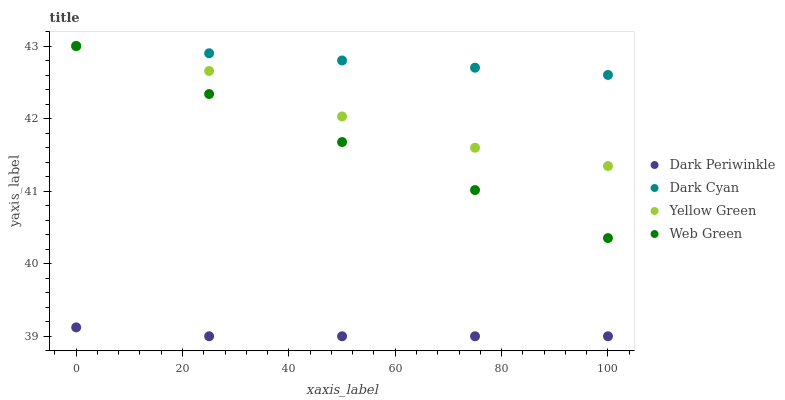Does Dark Periwinkle have the minimum area under the curve?
Answer yes or no. Yes. Does Dark Cyan have the maximum area under the curve?
Answer yes or no. Yes. Does Web Green have the minimum area under the curve?
Answer yes or no. No. Does Web Green have the maximum area under the curve?
Answer yes or no. No. Is Dark Cyan the smoothest?
Answer yes or no. Yes. Is Yellow Green the roughest?
Answer yes or no. Yes. Is Dark Periwinkle the smoothest?
Answer yes or no. No. Is Dark Periwinkle the roughest?
Answer yes or no. No. Does Dark Periwinkle have the lowest value?
Answer yes or no. Yes. Does Web Green have the lowest value?
Answer yes or no. No. Does Yellow Green have the highest value?
Answer yes or no. Yes. Does Dark Periwinkle have the highest value?
Answer yes or no. No. Is Dark Periwinkle less than Yellow Green?
Answer yes or no. Yes. Is Web Green greater than Dark Periwinkle?
Answer yes or no. Yes. Does Yellow Green intersect Dark Cyan?
Answer yes or no. Yes. Is Yellow Green less than Dark Cyan?
Answer yes or no. No. Is Yellow Green greater than Dark Cyan?
Answer yes or no. No. Does Dark Periwinkle intersect Yellow Green?
Answer yes or no. No. 